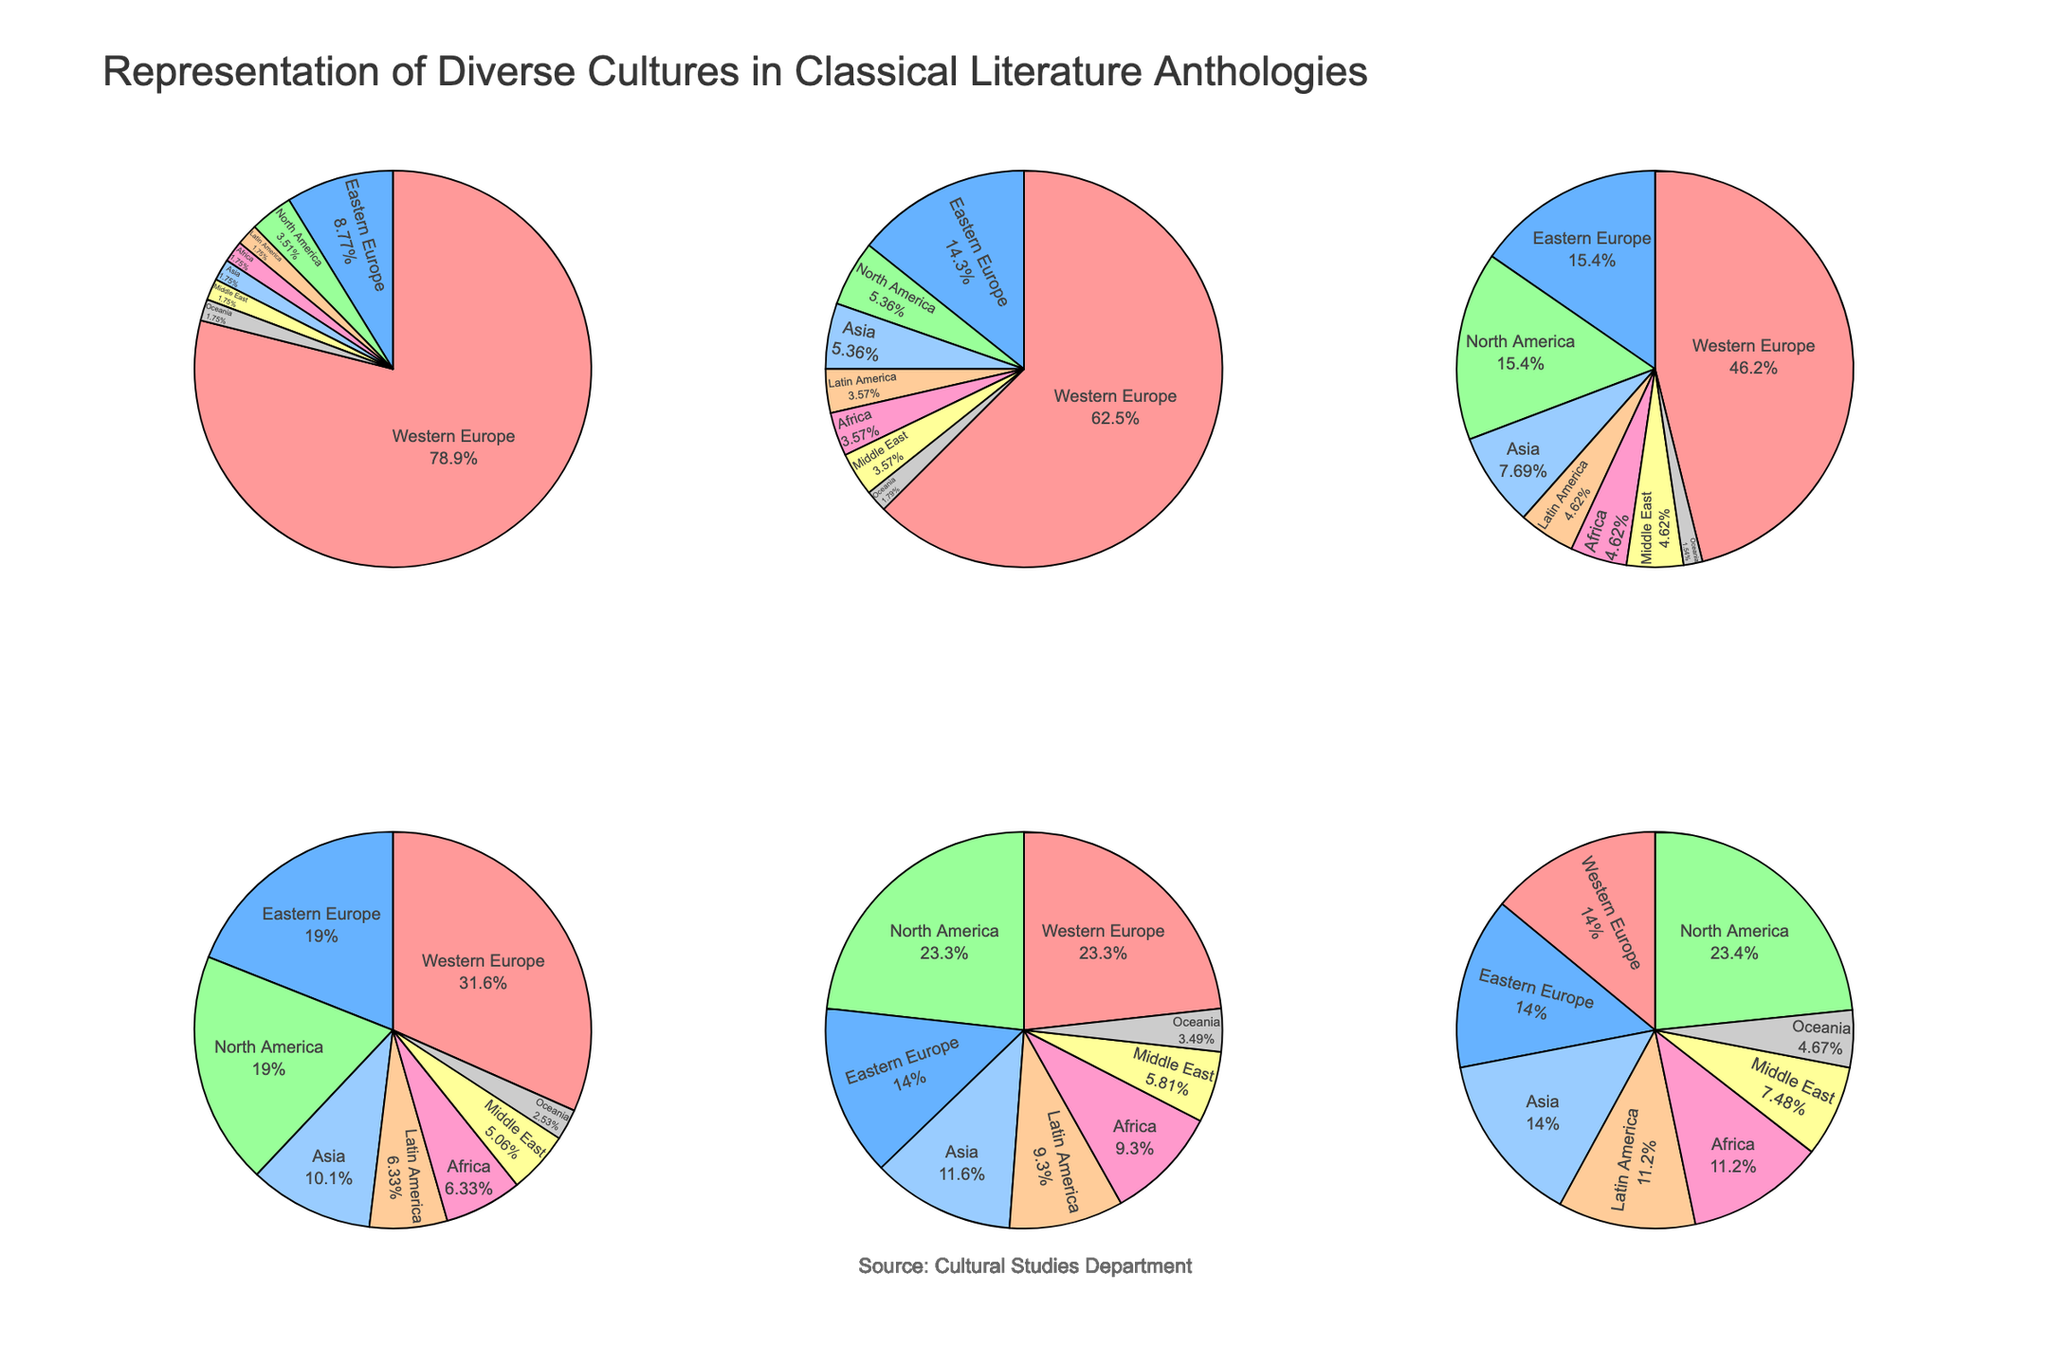Which region is most prominently represented in the 'Ancient Greek and Roman' period? Looking at the 'Ancient Greek and Roman' pie chart, Western Europe has the highest slice. Western Europe accounts for 45%.
Answer: Western Europe What is the overall trend in representation for Western Europe from 'Ancient Greek and Roman' to 'Modern'? Observing the pie charts from 'Ancient Greek and Roman' to 'Modern', the percentage of representation for Western Europe decreases steadily over time. It starts at 45% and drops to 15%.
Answer: Decreasing How does the diversity of regions change from the 'Renaissance' to the 'Modern' period? In the 'Renaissance' pie chart, Western Europe is highly dominant (35%), but by the 'Modern' period, multiple regions such as North America, Asia, and Africa have gained more representation. This indicates that diversity in regional representation increases over time.
Answer: Increases Which period shows the highest representation for North America? Refer to each period's pie chart and observe that the 'Modern' period has the largest slice for North America, with 25%.
Answer: Modern Compare the representation of Asia in the 'Enlightenment' and 'Romantic' periods. Which one has a larger percentage and by how much? The pie charts show that Asia has a 5% representation in the 'Enlightenment' period and 8% in the 'Romantic' period. The difference is 8% - 5% = 3%.
Answer: Romantic by 3% In which period does Latin America see the most significant representation? Looking at the pie charts, Latin America has its highest percentage in the 'Modern' period, with 12%.
Answer: Modern Calculate the total percentage represented by non-Western regions in the 'Victorian' period. The 'Victorian' pie chart shows non-Western regions (Eastern Europe, North America, Latin America, Africa, Asia, Middle East, Oceania) totaling 12% + 20% + 8% + 8% + 10% + 5% + 3% = 66%.
Answer: 66% Compare the sum of percentages for Africa and Asia during the 'Renaissance' and 'Modern' periods. Which period has a higher combined total, and by how much? For 'Renaissance', Africa (2%) + Asia (3%) = 5%. For 'Modern', Africa (12%) + Asia (15%) = 27%. The difference is 27% - 5% = 22%.
Answer: Modern by 22% Which region's representation remains constant across all periods? Observing all pie charts, Oceania's representation remains consistently low and almost constant at 1%-3% across all periods.
Answer: Oceania 